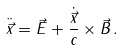Convert formula to latex. <formula><loc_0><loc_0><loc_500><loc_500>\ddot { \vec { x } } = \vec { E } + \frac { \dot { \vec { x } } } { c } \times \vec { B } \, .</formula> 